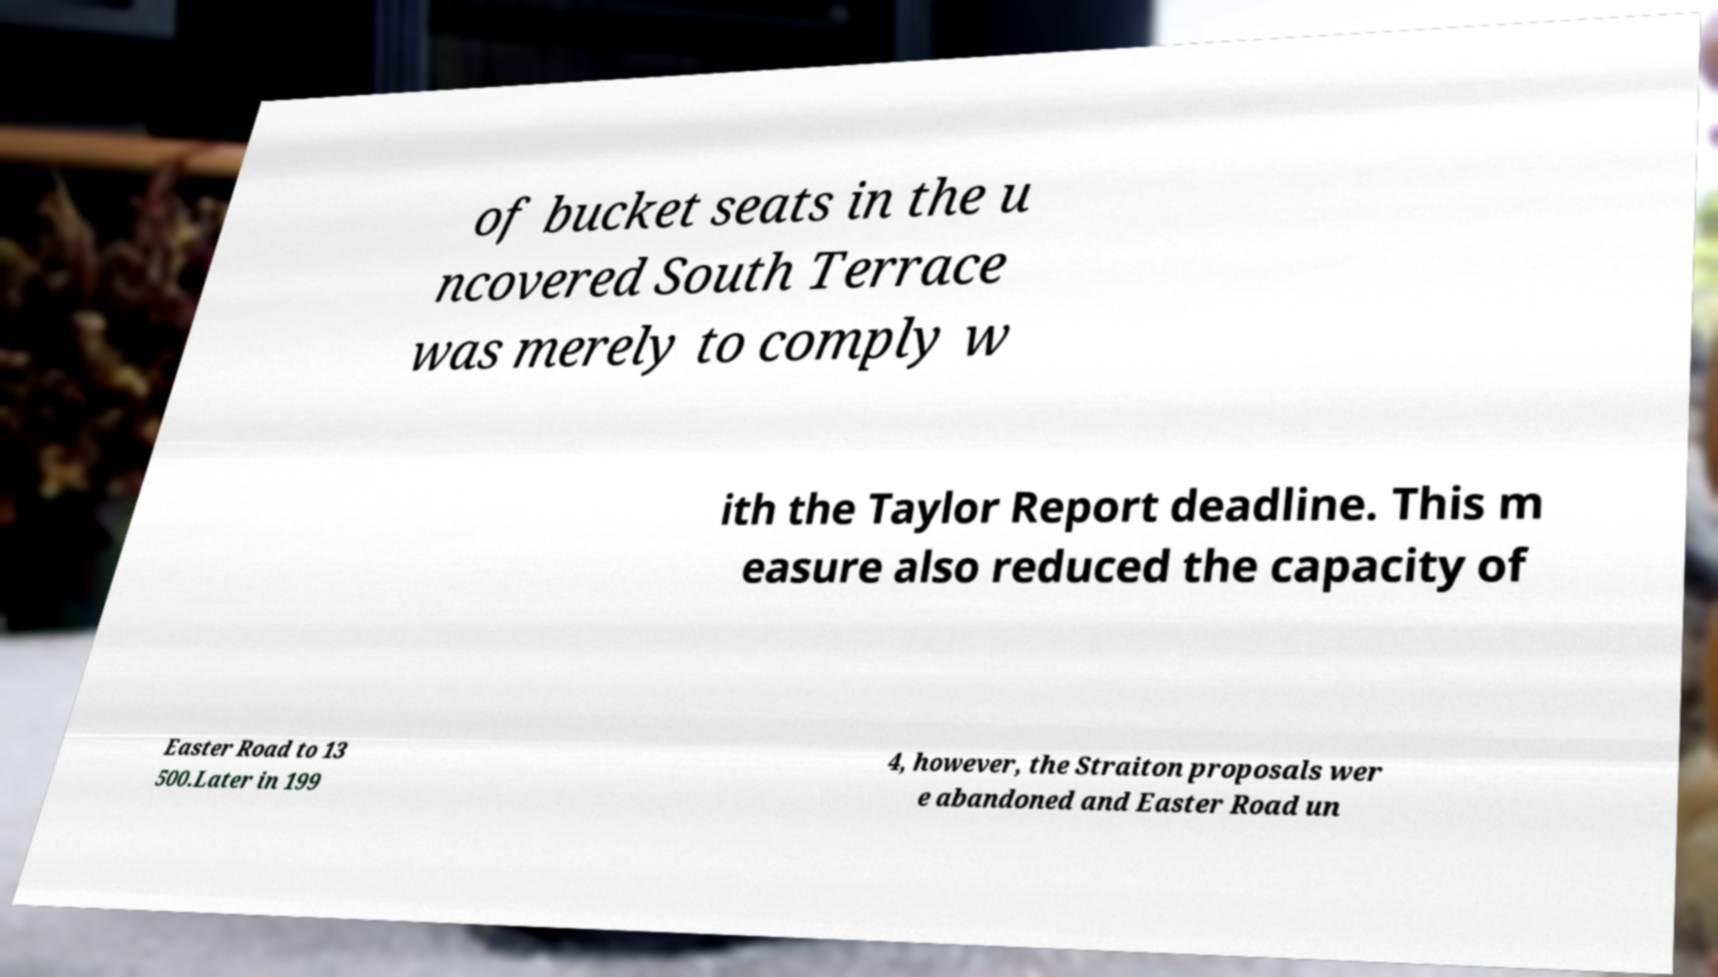There's text embedded in this image that I need extracted. Can you transcribe it verbatim? of bucket seats in the u ncovered South Terrace was merely to comply w ith the Taylor Report deadline. This m easure also reduced the capacity of Easter Road to 13 500.Later in 199 4, however, the Straiton proposals wer e abandoned and Easter Road un 